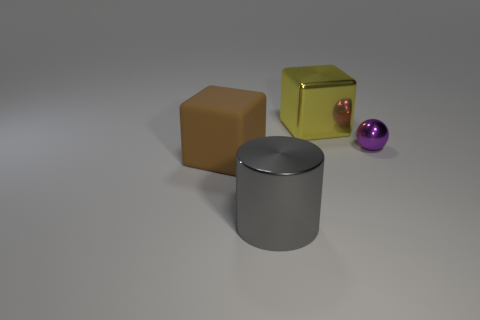Add 2 green shiny cylinders. How many objects exist? 6 Subtract all cylinders. How many objects are left? 3 Add 3 big cyan shiny cylinders. How many big cyan shiny cylinders exist? 3 Subtract 0 blue blocks. How many objects are left? 4 Subtract all big yellow shiny objects. Subtract all cyan cubes. How many objects are left? 3 Add 3 tiny things. How many tiny things are left? 4 